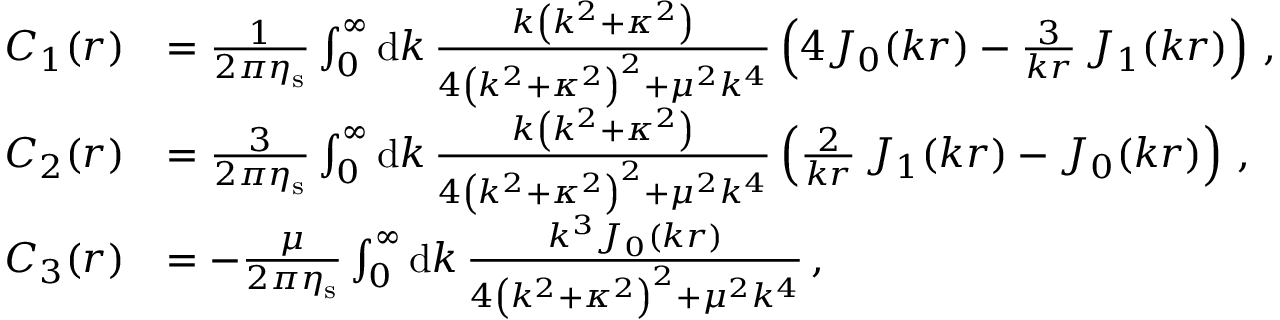Convert formula to latex. <formula><loc_0><loc_0><loc_500><loc_500>\begin{array} { r l } { C _ { 1 } ( r ) } & { = \frac { 1 } { 2 \pi \eta _ { s } } \int _ { 0 } ^ { \infty } d k \, \frac { k \left ( k ^ { 2 } + \kappa ^ { 2 } \right ) } { 4 \left ( k ^ { 2 } + \kappa ^ { 2 } \right ) ^ { 2 } + \mu ^ { 2 } k ^ { 4 } } \left ( 4 J _ { 0 } ( k r ) - \frac { 3 } { k r } \, J _ { 1 } ( k r ) \right ) \, , } \\ { C _ { 2 } ( r ) } & { = \frac { 3 } { 2 \pi \eta _ { s } } \int _ { 0 } ^ { \infty } d k \, \frac { k \left ( k ^ { 2 } + \kappa ^ { 2 } \right ) } { 4 \left ( k ^ { 2 } + \kappa ^ { 2 } \right ) ^ { 2 } + \mu ^ { 2 } k ^ { 4 } } \left ( \frac { 2 } { k r } \, J _ { 1 } ( k r ) - J _ { 0 } ( k r ) \right ) \, , } \\ { C _ { 3 } ( r ) } & { = - \frac { \mu } { 2 \pi \eta _ { s } } \int _ { 0 } ^ { \infty } d k \, \frac { k ^ { 3 } J _ { 0 } ( k r ) } { 4 \left ( k ^ { 2 } + \kappa ^ { 2 } \right ) ^ { 2 } + \mu ^ { 2 } k ^ { 4 } } \, , } \end{array}</formula> 